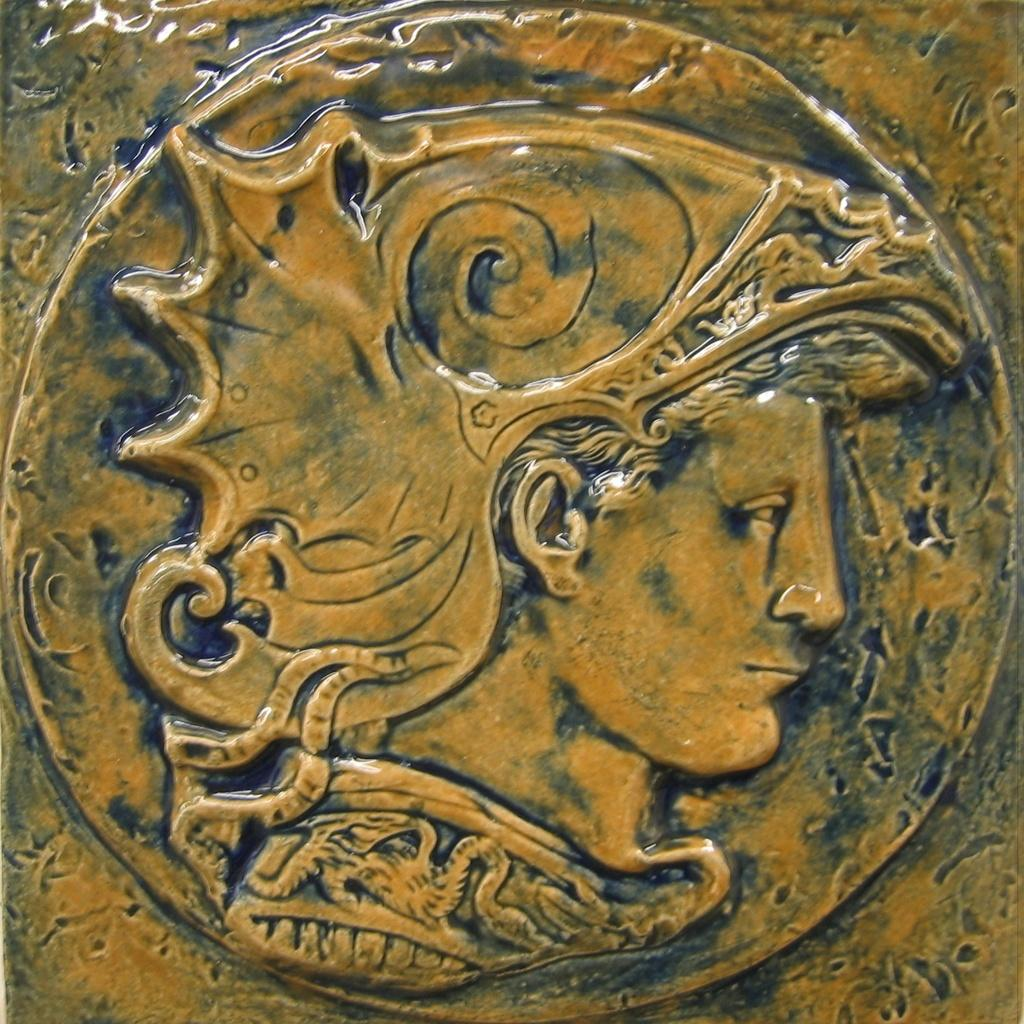What is the main feature in the center of the image? There is a carving on the wall in the center of the image. What does the carving depict? The carving depicts a human face. How many legs does the human face have in the image? The human face depicted in the carving does not have legs, as it is a facial representation. 